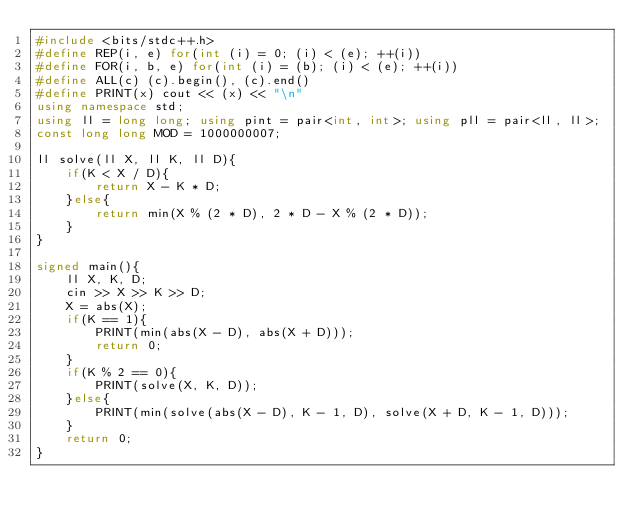<code> <loc_0><loc_0><loc_500><loc_500><_C++_>#include <bits/stdc++.h>
#define REP(i, e) for(int (i) = 0; (i) < (e); ++(i))
#define FOR(i, b, e) for(int (i) = (b); (i) < (e); ++(i))
#define ALL(c) (c).begin(), (c).end()
#define PRINT(x) cout << (x) << "\n"
using namespace std;
using ll = long long; using pint = pair<int, int>; using pll = pair<ll, ll>;
const long long MOD = 1000000007;

ll solve(ll X, ll K, ll D){
    if(K < X / D){
        return X - K * D;
    }else{
        return min(X % (2 * D), 2 * D - X % (2 * D));
    }
}

signed main(){
    ll X, K, D;
    cin >> X >> K >> D;
    X = abs(X);
    if(K == 1){
        PRINT(min(abs(X - D), abs(X + D)));
        return 0;
    }
    if(K % 2 == 0){
        PRINT(solve(X, K, D));
    }else{
        PRINT(min(solve(abs(X - D), K - 1, D), solve(X + D, K - 1, D)));
    }
    return 0;
}</code> 